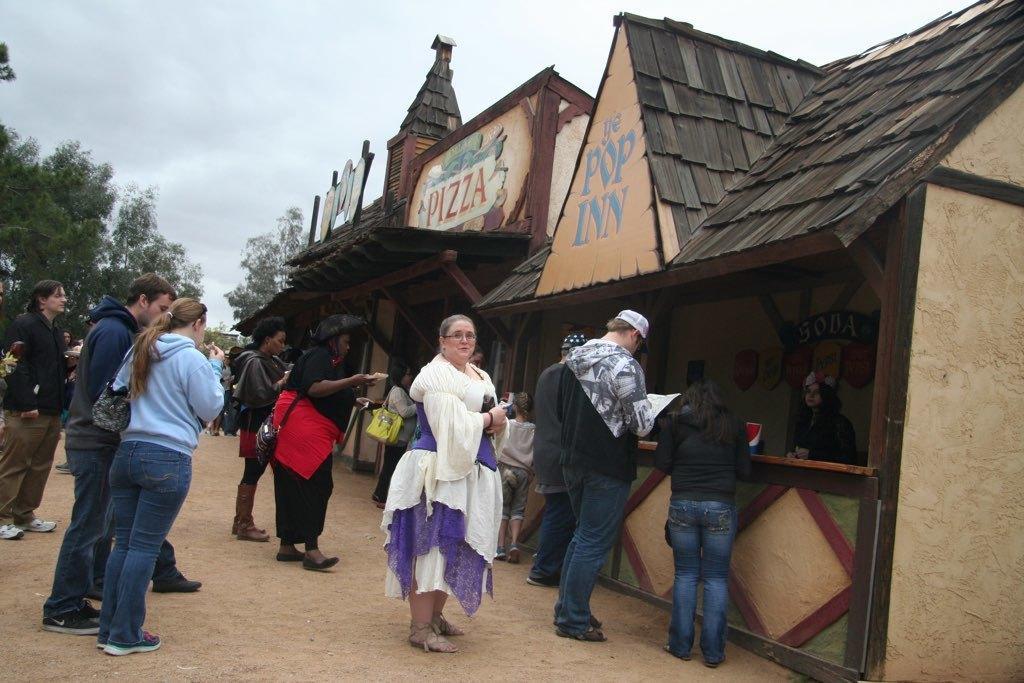Describe this image in one or two sentences. In this image I can see group of people some standing and some are eating. I can also see few stalls. Background I can see trees in green color and sky in white color. 